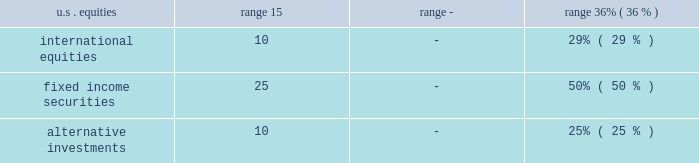Pension plan assets pension assets include public equities , government and corporate bonds , cash and cash equivalents , private real estate funds , private partnerships , hedge funds , and other assets .
Plan assets are held in a master trust and overseen by the company's investment committee .
All assets are externally managed through a combination of active and passive strategies .
Managers may only invest in the asset classes for which they have been appointed .
The investment committee is responsible for setting the policy that provides the framework for management of the plan assets .
The investment committee has set the minimum and maximum permitted values for each asset class in the company's pension plan master trust for the year ended december 31 , 2018 , as follows: .
The general objectives of the company's pension asset strategy are to earn a rate of return over time to satisfy the benefit obligations of the plans , meet minimum erisa funding requirements , and maintain sufficient liquidity to pay benefits and address other cash requirements within the master trust .
Specific investment objectives include reducing the volatility of pension assets relative to benefit obligations , achieving a competitive , total investment return , achieving diversification between and within asset classes , and managing other risks .
Investment objectives for each asset class are determined based on specific risks and investment opportunities identified .
Decisions regarding investment policies and asset allocation are made with the understanding of the historical and prospective return and risk characteristics of various asset classes , the effect of asset allocations on funded status , future company contributions , and projected expenditures , including benefits .
The company updates its asset allocations periodically .
The company uses various analytics to determine the optimal asset mix and considers plan obligation characteristics , duration , liquidity characteristics , funding requirements , expected rates of return , regular rebalancing , and the distribution of returns .
Actual allocations to each asset class could vary from target allocations due to periodic investment strategy changes , short-term market value fluctuations , the length of time it takes to fully implement investment allocation positions , such as real estate and other alternative investments , and the timing of benefit payments and company contributions .
Taking into account the asset allocation ranges , the company determines the specific allocation of the master trust's investments within various asset classes .
The master trust utilizes select investment strategies , which are executed through separate account or fund structures with external investment managers who demonstrate experience and expertise in the appropriate asset classes and styles .
The selection of investment managers is done with careful evaluation of all aspects of performance and risk , demonstrated fiduciary responsibility , investment management experience , and a review of the investment managers' policies and processes .
Investment performance is monitored frequently against appropriate benchmarks and tracked to compliance guidelines with the assistance of third party consultants and performance evaluation tools and metrics .
Plan assets are stated at fair value .
The company employs a variety of pricing sources to estimate the fair value of its pension plan assets , including independent pricing vendors , dealer or counterparty-supplied valuations , third- party appraisals , and appraisals prepared by the company's investment managers or other experts .
Investments in equity securities , common and preferred , are valued at the last reported sales price when an active market exists .
Securities for which official or last trade pricing on an active exchange is available are classified as level 1 .
If closing prices are not available , securities are valued at the last trade price , if deemed reasonable , or a broker's quote in a non-active market , and are typically categorized as level 2 .
Investments in fixed-income securities are generally valued by independent pricing services or dealers who make markets in such securities .
Pricing methods are based upon market transactions for comparable securities and various relationships between securities that are generally recognized by institutional traders , and fixed-income securities typically are categorized as level 2. .
What is the difference in the range of u.s equities permitted in the company's pension plan? 
Computations: (36% - 15)
Answer: -14.64. 